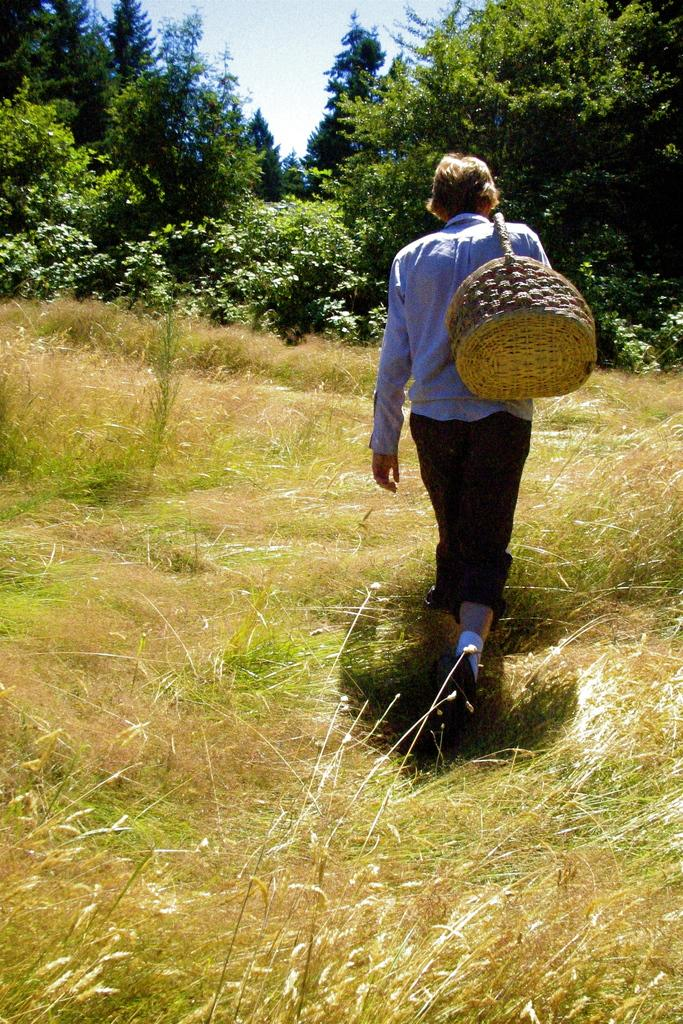What is the person in the image doing? The person is standing on the ground in the image. What is the surface beneath the person's feet? The ground is covered in greenery. What is the person holding or carrying in the image? The person is carrying an object. What can be seen in the distance behind the person? There are trees in the background of the image. Can you see the person's lips in the image? There is no specific mention of the person's lips in the image, so it cannot be determined if they are visible or not. 